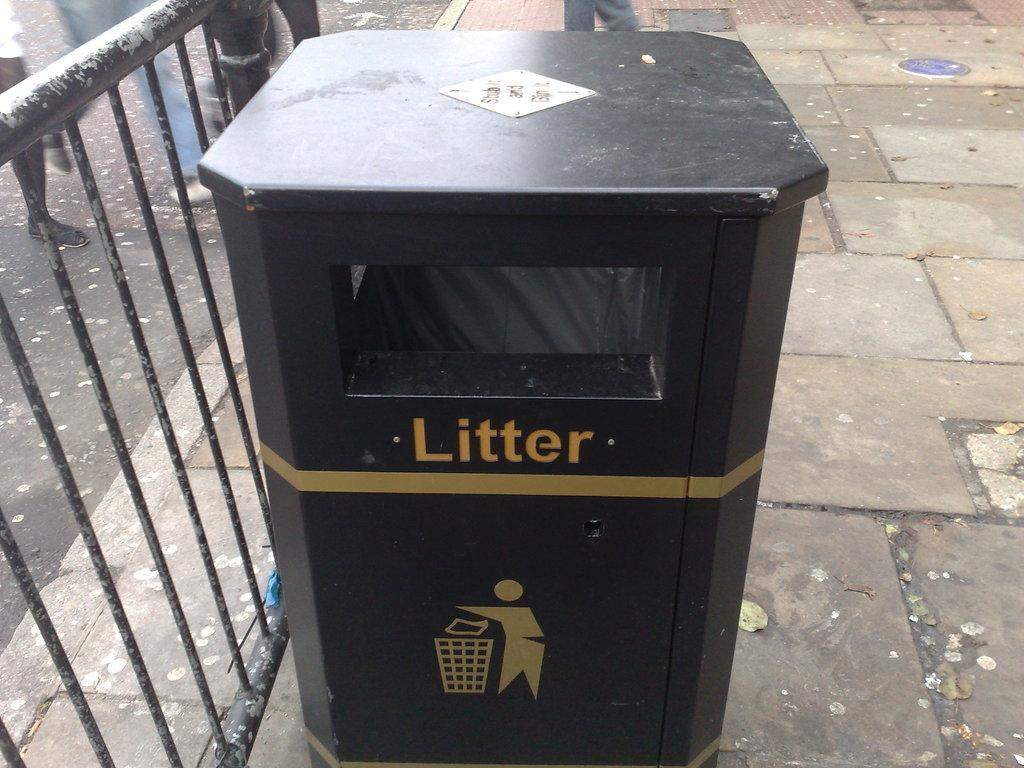<image>
Present a compact description of the photo's key features. a trash can outside that is labeled with the word 'litter' 